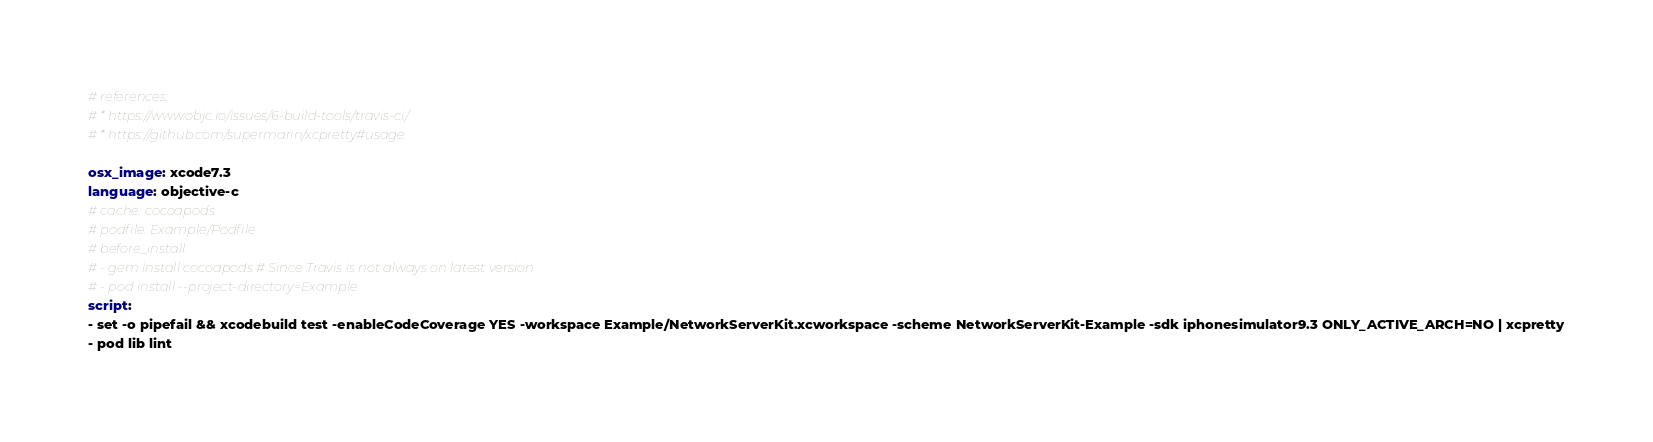<code> <loc_0><loc_0><loc_500><loc_500><_YAML_># references:
# * https://www.objc.io/issues/6-build-tools/travis-ci/
# * https://github.com/supermarin/xcpretty#usage

osx_image: xcode7.3
language: objective-c
# cache: cocoapods
# podfile: Example/Podfile
# before_install:
# - gem install cocoapods # Since Travis is not always on latest version
# - pod install --project-directory=Example
script:
- set -o pipefail && xcodebuild test -enableCodeCoverage YES -workspace Example/NetworkServerKit.xcworkspace -scheme NetworkServerKit-Example -sdk iphonesimulator9.3 ONLY_ACTIVE_ARCH=NO | xcpretty
- pod lib lint
</code> 